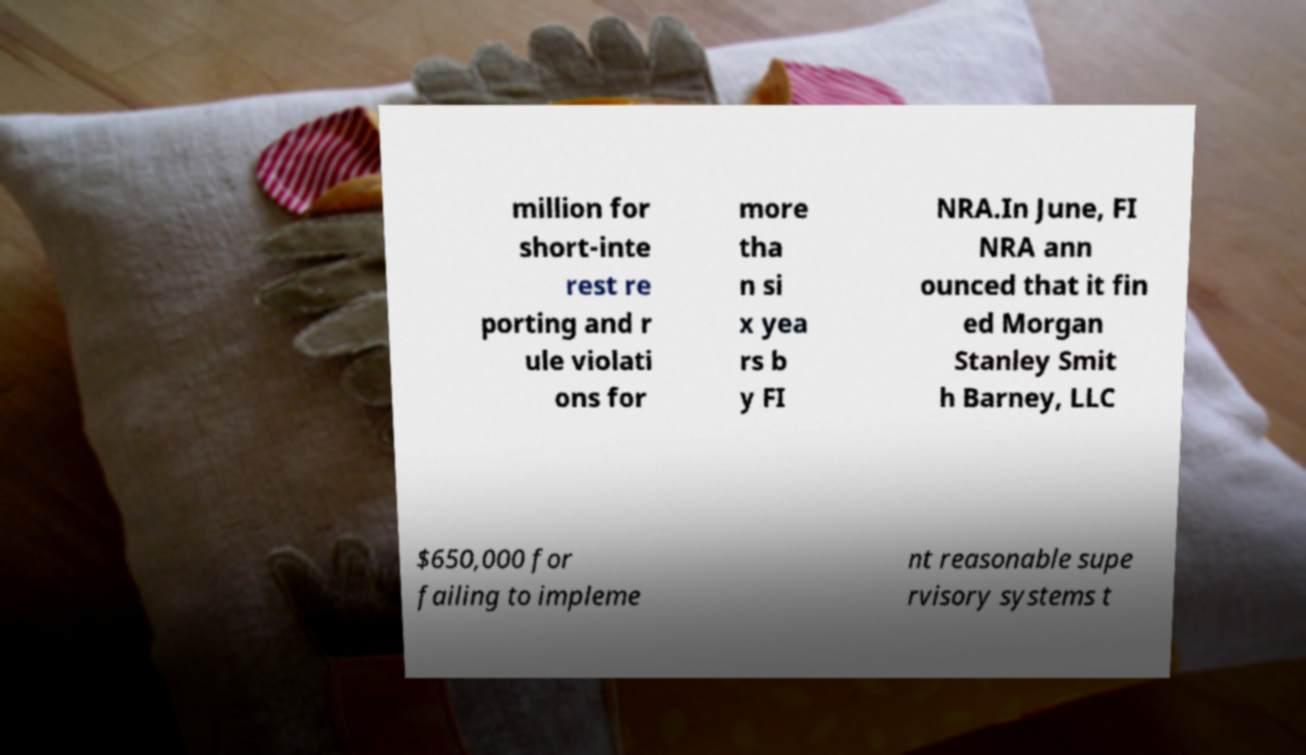What messages or text are displayed in this image? I need them in a readable, typed format. million for short-inte rest re porting and r ule violati ons for more tha n si x yea rs b y FI NRA.In June, FI NRA ann ounced that it fin ed Morgan Stanley Smit h Barney, LLC $650,000 for failing to impleme nt reasonable supe rvisory systems t 